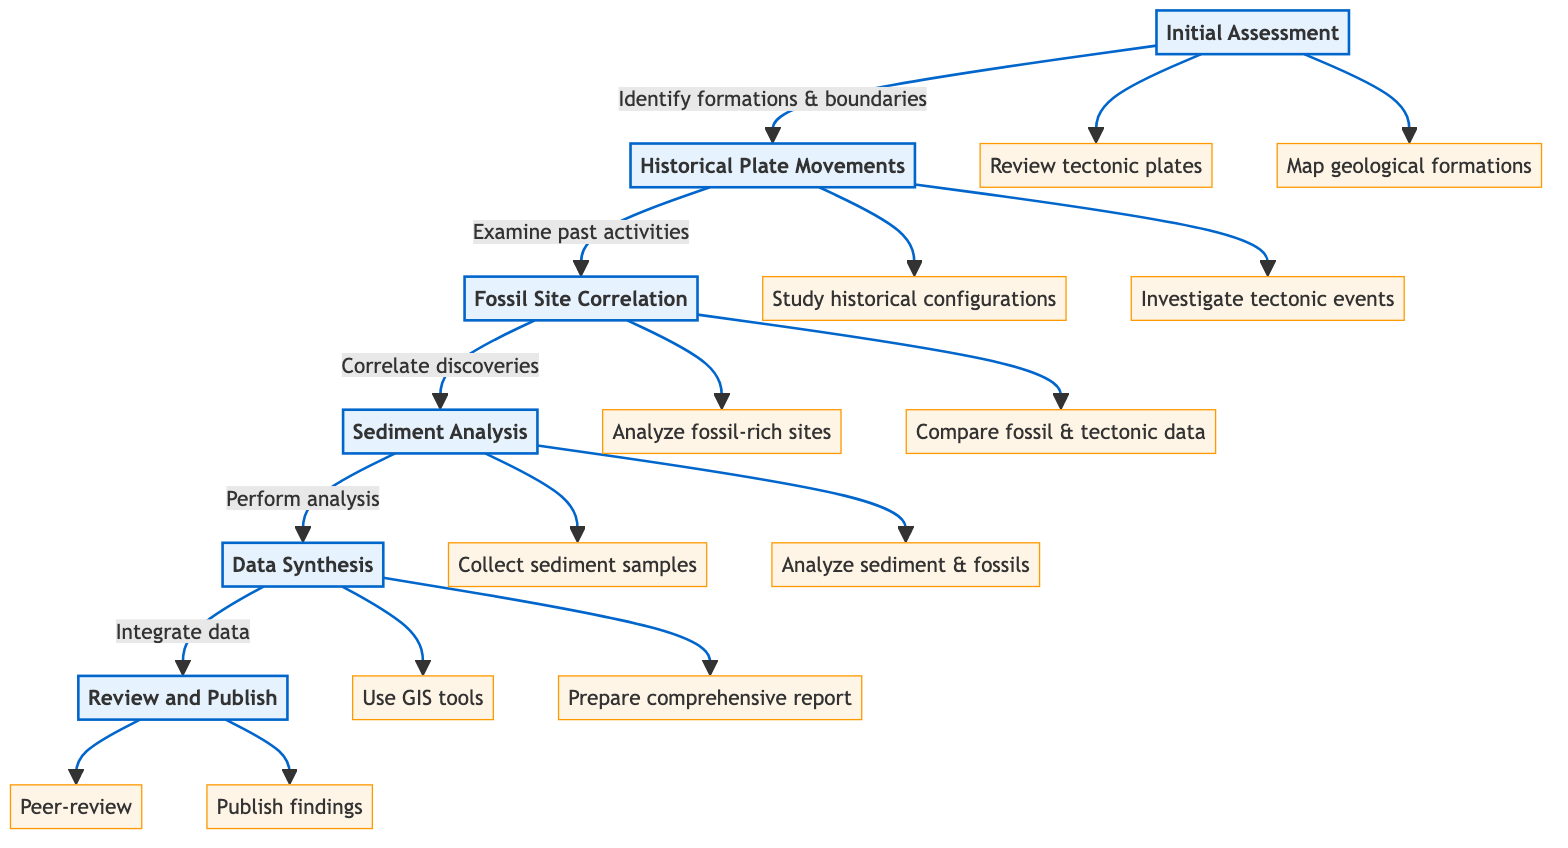What is the first step in the clinical pathway? The first step in the pathway is labeled as "1" and is titled "Initial Assessment".
Answer: Initial Assessment How many steps are there in the clinical pathway? By counting the listed steps in the diagram, there are a total of six steps from "Initial Assessment" to "Review and Publish".
Answer: 6 Which step directly follows "Fossil Site Correlation"? In the sequence flow of the diagram, "Fossil Site Correlation" (Step 3) is followed by "Sediment Analysis" (Step 4).
Answer: Sediment Analysis What is the last task listed under "Review and Publish"? The last task under the "Review and Publish" step is identified as publishing findings in Earth Science journals, which is denoted as "Publish findings".
Answer: Publish findings What are the two tasks associated with "Data Synthesis"? The tasks associated with "Data Synthesis" are: "Use GIS tools to visualize data integration" and "Prepare comprehensive report on the impact of plate tectonics on fossil distribution".
Answer: Use GIS tools, Prepare comprehensive report How does "Historical Plate Movements" relate to "Initial Assessment"? "Historical Plate Movements" directly follows "Initial Assessment" in the clinical pathway, indicating a sequential relationship, as it is Step 2.
Answer: Directly follows What type of analysis is performed at key locations? The task in the "Sediment Analysis" step specifies performing a sediment analysis, which involves analyzing sediment composition and fossil content at key locations.
Answer: Sediment Analysis What is required before publishing findings? Before findings can be published, they must undergo a peer-review process by experts in geology and paleontology, as indicated in the "Review and Publish" step.
Answer: Peer-review What is the purpose of mapping geological formations in the clinical pathway? Mapping geological formations is part of the "Initial Assessment", which aims to identify significant plate boundaries and formations, thus serving as a foundational task for the entire pathway.
Answer: Identify significant plate boundaries and formations 